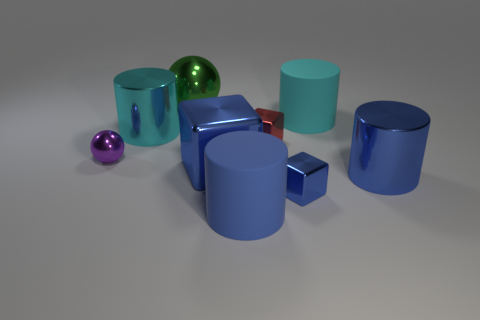Subtract all brown cylinders. Subtract all brown spheres. How many cylinders are left? 4 Subtract all cylinders. How many objects are left? 5 Add 3 tiny cubes. How many tiny cubes exist? 5 Subtract 0 cyan blocks. How many objects are left? 9 Subtract all small purple spheres. Subtract all small red things. How many objects are left? 7 Add 6 metallic spheres. How many metallic spheres are left? 8 